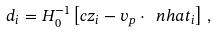Convert formula to latex. <formula><loc_0><loc_0><loc_500><loc_500>d _ { i } = H _ { 0 } ^ { - 1 } \left [ c z _ { i } - v _ { p } \cdot \ n h a t _ { i } \right ] \, ,</formula> 